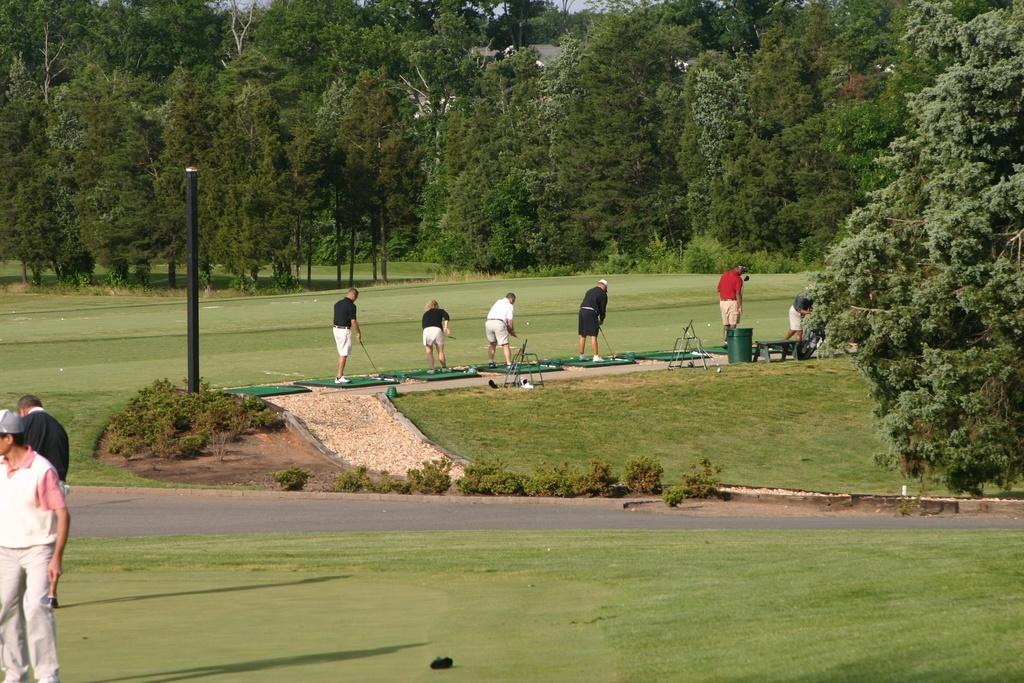In one or two sentences, can you explain what this image depicts? On the left side of the image we can see persons, grass and pole. In the center of the image we can see many persons standing on the grass and holding a bats. On the right side of the image we can see a tree. In the background we can see trees, grass and plants. 